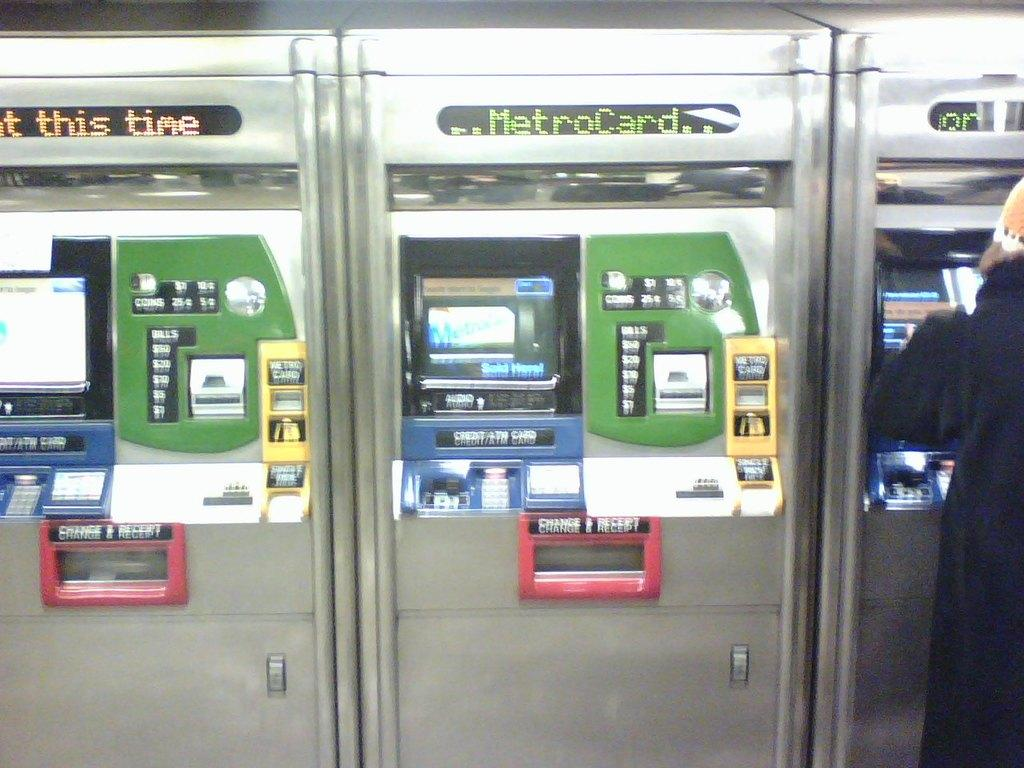What type of machines are present in the image? There are automatic ticket vending machines in the image. Can you describe the person in the image? There is a person on the right side of the image. What type of test is the person taking in the image? There is no test present in the image; it only shows a person and automatic ticket vending machines. 